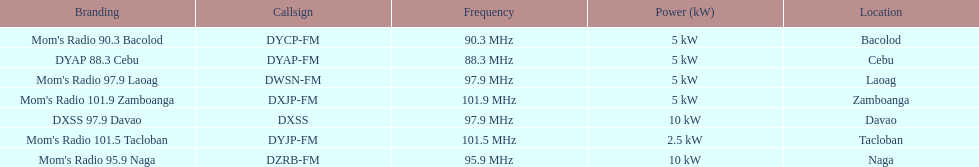Which of these stations broadcasts with the least power? Mom's Radio 101.5 Tacloban. 